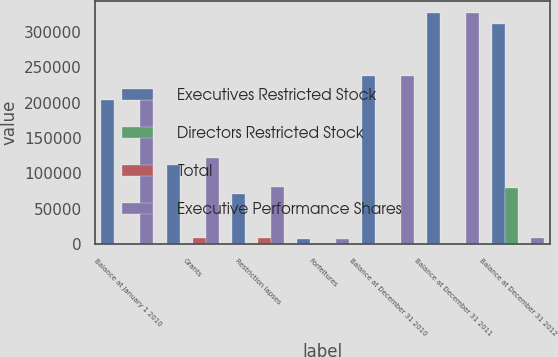<chart> <loc_0><loc_0><loc_500><loc_500><stacked_bar_chart><ecel><fcel>Balance at January 1 2010<fcel>Grants<fcel>Restriction lapses<fcel>Forfeitures<fcel>Balance at December 31 2010<fcel>Balance at December 31 2011<fcel>Balance at December 31 2012<nl><fcel>Executives Restricted Stock<fcel>203250<fcel>112500<fcel>71100<fcel>7500<fcel>237150<fcel>327000<fcel>311700<nl><fcel>Directors Restricted Stock<fcel>0<fcel>0<fcel>0<fcel>0<fcel>0<fcel>0<fcel>80000<nl><fcel>Total<fcel>0<fcel>9423<fcel>9423<fcel>0<fcel>0<fcel>0<fcel>0<nl><fcel>Executive Performance Shares<fcel>203250<fcel>121923<fcel>80523<fcel>7500<fcel>237150<fcel>327000<fcel>9423<nl></chart> 